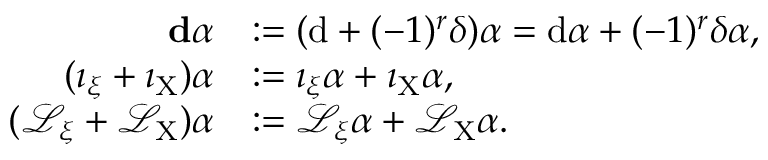<formula> <loc_0><loc_0><loc_500><loc_500>\begin{array} { r l } { d \alpha } & { \colon = ( d + ( - 1 ) ^ { r } \delta ) \alpha = d \alpha + ( - 1 ) ^ { r } \delta \alpha , } \\ { ( \imath _ { \xi } + \imath _ { X } ) \alpha } & { \colon = \imath _ { \xi } \alpha + \imath _ { X } \alpha , } \\ { ( \mathcal { L } _ { \xi } + \mathcal { L } _ { X } ) \alpha } & { \colon = \mathcal { L } _ { \xi } \alpha + \mathcal { L } _ { X } \alpha . } \end{array}</formula> 